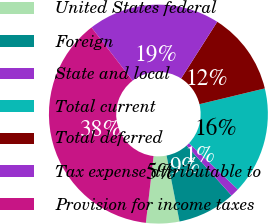Convert chart. <chart><loc_0><loc_0><loc_500><loc_500><pie_chart><fcel>United States federal<fcel>Foreign<fcel>State and local<fcel>Total current<fcel>Total deferred<fcel>Tax expense attributable to<fcel>Provision for income taxes<nl><fcel>4.92%<fcel>8.56%<fcel>1.27%<fcel>15.85%<fcel>12.2%<fcel>19.49%<fcel>37.71%<nl></chart> 